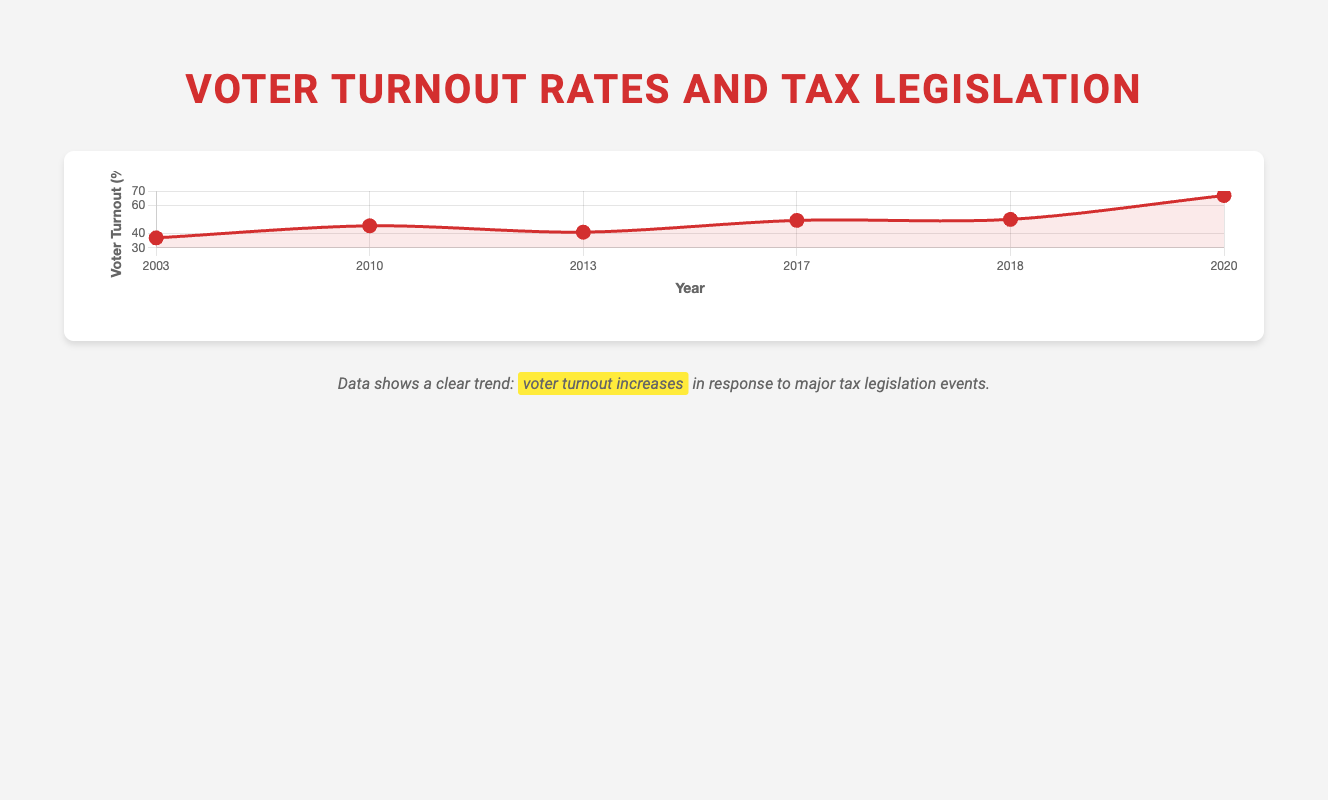What's the voter turnout rate in 2003? The figure shows that in 2003, during the Bush Tax Cuts, the voter turnout rate is indicated by a point on the line chart. This point is at 37.0%.
Answer: 37.0% Compare the voter turnout rates between 2010 and 2013. Which year had a higher turnout? Referring to the line chart, the voter turnout rate in 2010 was 45.5%, while in 2013, it was 41.0%. Comparing these two values, 2010 had a higher turnout.
Answer: 2010 What is the difference in voter turnout between the events in 2017 and 2020? The voter turnout rate in 2017 during Trump's Tax Cuts and Jobs Act was 49.3%, and in 2020 during Biden's Tax Increase Proposal, it was 66.8%. The difference can be calculated as 66.8 - 49.3 = 17.5%.
Answer: 17.5% What is the average voter turnout rate across all the years displayed? To find the average voter turnout, add all the voter turnout rates and divide by the number of data points: (37.0 + 45.5 + 41.0 + 49.3 + 50.0 + 66.8) / 6 = 48.27%.
Answer: 48.27% Between which two consecutive events did the voter turnout rate decrease? By examining the line chart, we see that the voter turnout rate decreases between 2010 (45.5%) and 2013 (41.0%).
Answer: 2010 and 2013 Which year saw the highest voter turnout rate in response to a major tax legislation event? The highest point on the line chart corresponds to the year 2020, with a voter turnout rate of 66.8%.
Answer: 2020 How does the voter turnout in 2018 compare to the average voter turnout rate across all years shown? The average voter turnout rate across all years is 48.27%. In 2018, the voter turnout rate was 50.0%, which is higher than the average.
Answer: Higher What trend can be observed in the voter turnout rates from 2003 to 2020? Observing the line chart, there is an overall increasing trend in voter turnout rates from 2003 (37.0%) to 2020 (66.8%).
Answer: Increasing What is the median voter turnout rate for the data set? To find the median, first order the voter turnout rates: 37.0, 41.0, 45.5, 49.3, 50.0, 66.8. The median is the average of the middle two values: (45.5 + 49.3) / 2 = 47.4%.
Answer: 47.4% 